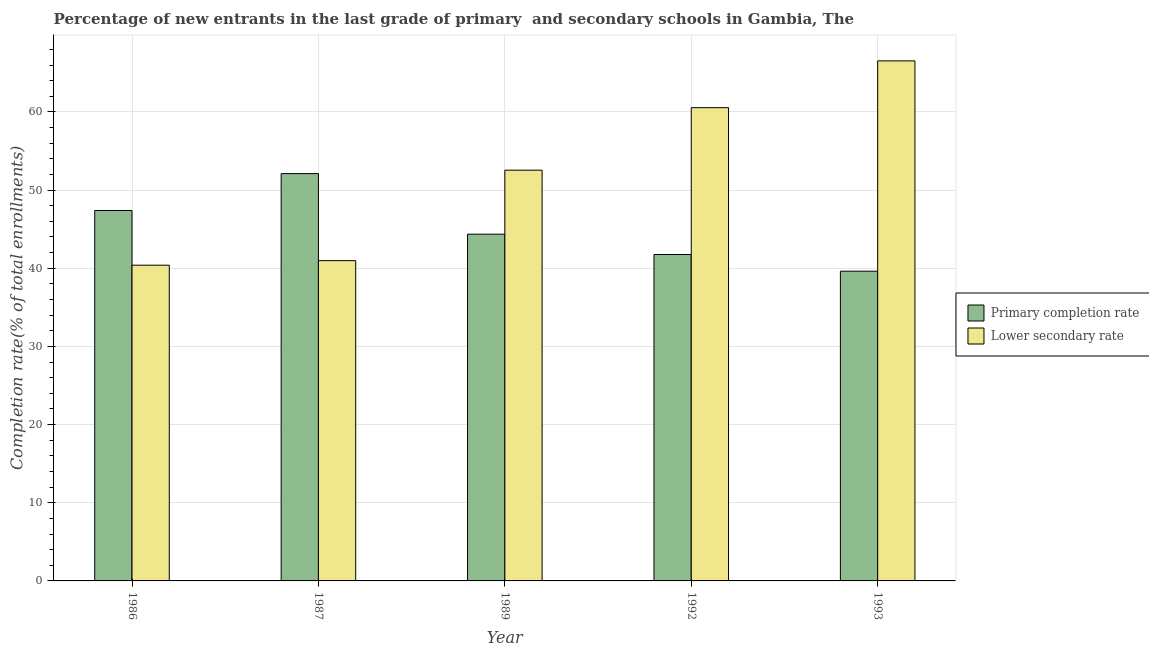Are the number of bars per tick equal to the number of legend labels?
Your response must be concise. Yes. How many bars are there on the 4th tick from the left?
Keep it short and to the point. 2. How many bars are there on the 4th tick from the right?
Your response must be concise. 2. What is the label of the 2nd group of bars from the left?
Provide a succinct answer. 1987. In how many cases, is the number of bars for a given year not equal to the number of legend labels?
Provide a succinct answer. 0. What is the completion rate in secondary schools in 1987?
Make the answer very short. 40.97. Across all years, what is the maximum completion rate in primary schools?
Offer a very short reply. 52.11. Across all years, what is the minimum completion rate in secondary schools?
Offer a very short reply. 40.39. In which year was the completion rate in primary schools maximum?
Give a very brief answer. 1987. What is the total completion rate in primary schools in the graph?
Keep it short and to the point. 225.23. What is the difference between the completion rate in secondary schools in 1989 and that in 1992?
Your answer should be compact. -8. What is the difference between the completion rate in primary schools in 1989 and the completion rate in secondary schools in 1992?
Provide a succinct answer. 2.6. What is the average completion rate in secondary schools per year?
Give a very brief answer. 52.2. In the year 1987, what is the difference between the completion rate in primary schools and completion rate in secondary schools?
Make the answer very short. 0. In how many years, is the completion rate in primary schools greater than 14 %?
Your response must be concise. 5. What is the ratio of the completion rate in primary schools in 1992 to that in 1993?
Keep it short and to the point. 1.05. Is the completion rate in primary schools in 1986 less than that in 1987?
Give a very brief answer. Yes. What is the difference between the highest and the second highest completion rate in primary schools?
Your response must be concise. 4.72. What is the difference between the highest and the lowest completion rate in secondary schools?
Your response must be concise. 26.14. What does the 2nd bar from the left in 1986 represents?
Your response must be concise. Lower secondary rate. What does the 2nd bar from the right in 1986 represents?
Provide a succinct answer. Primary completion rate. How many bars are there?
Give a very brief answer. 10. How many years are there in the graph?
Your answer should be very brief. 5. What is the difference between two consecutive major ticks on the Y-axis?
Make the answer very short. 10. Are the values on the major ticks of Y-axis written in scientific E-notation?
Your answer should be compact. No. Where does the legend appear in the graph?
Provide a short and direct response. Center right. What is the title of the graph?
Give a very brief answer. Percentage of new entrants in the last grade of primary  and secondary schools in Gambia, The. Does "Overweight" appear as one of the legend labels in the graph?
Make the answer very short. No. What is the label or title of the X-axis?
Your answer should be compact. Year. What is the label or title of the Y-axis?
Your response must be concise. Completion rate(% of total enrollments). What is the Completion rate(% of total enrollments) of Primary completion rate in 1986?
Offer a terse response. 47.39. What is the Completion rate(% of total enrollments) in Lower secondary rate in 1986?
Provide a succinct answer. 40.39. What is the Completion rate(% of total enrollments) in Primary completion rate in 1987?
Keep it short and to the point. 52.11. What is the Completion rate(% of total enrollments) in Lower secondary rate in 1987?
Ensure brevity in your answer.  40.97. What is the Completion rate(% of total enrollments) of Primary completion rate in 1989?
Offer a very short reply. 44.36. What is the Completion rate(% of total enrollments) of Lower secondary rate in 1989?
Provide a short and direct response. 52.55. What is the Completion rate(% of total enrollments) in Primary completion rate in 1992?
Provide a succinct answer. 41.76. What is the Completion rate(% of total enrollments) in Lower secondary rate in 1992?
Ensure brevity in your answer.  60.54. What is the Completion rate(% of total enrollments) of Primary completion rate in 1993?
Ensure brevity in your answer.  39.63. What is the Completion rate(% of total enrollments) in Lower secondary rate in 1993?
Keep it short and to the point. 66.53. Across all years, what is the maximum Completion rate(% of total enrollments) of Primary completion rate?
Your response must be concise. 52.11. Across all years, what is the maximum Completion rate(% of total enrollments) of Lower secondary rate?
Offer a very short reply. 66.53. Across all years, what is the minimum Completion rate(% of total enrollments) of Primary completion rate?
Offer a very short reply. 39.63. Across all years, what is the minimum Completion rate(% of total enrollments) in Lower secondary rate?
Offer a very short reply. 40.39. What is the total Completion rate(% of total enrollments) of Primary completion rate in the graph?
Keep it short and to the point. 225.23. What is the total Completion rate(% of total enrollments) in Lower secondary rate in the graph?
Provide a short and direct response. 260.98. What is the difference between the Completion rate(% of total enrollments) of Primary completion rate in 1986 and that in 1987?
Give a very brief answer. -4.72. What is the difference between the Completion rate(% of total enrollments) in Lower secondary rate in 1986 and that in 1987?
Offer a very short reply. -0.58. What is the difference between the Completion rate(% of total enrollments) in Primary completion rate in 1986 and that in 1989?
Your response must be concise. 3.03. What is the difference between the Completion rate(% of total enrollments) in Lower secondary rate in 1986 and that in 1989?
Provide a succinct answer. -12.15. What is the difference between the Completion rate(% of total enrollments) of Primary completion rate in 1986 and that in 1992?
Make the answer very short. 5.63. What is the difference between the Completion rate(% of total enrollments) in Lower secondary rate in 1986 and that in 1992?
Offer a terse response. -20.15. What is the difference between the Completion rate(% of total enrollments) of Primary completion rate in 1986 and that in 1993?
Keep it short and to the point. 7.76. What is the difference between the Completion rate(% of total enrollments) in Lower secondary rate in 1986 and that in 1993?
Give a very brief answer. -26.14. What is the difference between the Completion rate(% of total enrollments) in Primary completion rate in 1987 and that in 1989?
Provide a short and direct response. 7.75. What is the difference between the Completion rate(% of total enrollments) in Lower secondary rate in 1987 and that in 1989?
Keep it short and to the point. -11.57. What is the difference between the Completion rate(% of total enrollments) of Primary completion rate in 1987 and that in 1992?
Your answer should be compact. 10.35. What is the difference between the Completion rate(% of total enrollments) of Lower secondary rate in 1987 and that in 1992?
Ensure brevity in your answer.  -19.57. What is the difference between the Completion rate(% of total enrollments) of Primary completion rate in 1987 and that in 1993?
Your answer should be very brief. 12.48. What is the difference between the Completion rate(% of total enrollments) in Lower secondary rate in 1987 and that in 1993?
Your response must be concise. -25.56. What is the difference between the Completion rate(% of total enrollments) in Primary completion rate in 1989 and that in 1992?
Make the answer very short. 2.6. What is the difference between the Completion rate(% of total enrollments) of Lower secondary rate in 1989 and that in 1992?
Provide a succinct answer. -8. What is the difference between the Completion rate(% of total enrollments) in Primary completion rate in 1989 and that in 1993?
Your answer should be very brief. 4.73. What is the difference between the Completion rate(% of total enrollments) in Lower secondary rate in 1989 and that in 1993?
Keep it short and to the point. -13.98. What is the difference between the Completion rate(% of total enrollments) in Primary completion rate in 1992 and that in 1993?
Offer a terse response. 2.13. What is the difference between the Completion rate(% of total enrollments) in Lower secondary rate in 1992 and that in 1993?
Give a very brief answer. -5.99. What is the difference between the Completion rate(% of total enrollments) in Primary completion rate in 1986 and the Completion rate(% of total enrollments) in Lower secondary rate in 1987?
Offer a very short reply. 6.41. What is the difference between the Completion rate(% of total enrollments) in Primary completion rate in 1986 and the Completion rate(% of total enrollments) in Lower secondary rate in 1989?
Keep it short and to the point. -5.16. What is the difference between the Completion rate(% of total enrollments) in Primary completion rate in 1986 and the Completion rate(% of total enrollments) in Lower secondary rate in 1992?
Offer a terse response. -13.16. What is the difference between the Completion rate(% of total enrollments) in Primary completion rate in 1986 and the Completion rate(% of total enrollments) in Lower secondary rate in 1993?
Provide a succinct answer. -19.14. What is the difference between the Completion rate(% of total enrollments) of Primary completion rate in 1987 and the Completion rate(% of total enrollments) of Lower secondary rate in 1989?
Your answer should be very brief. -0.44. What is the difference between the Completion rate(% of total enrollments) of Primary completion rate in 1987 and the Completion rate(% of total enrollments) of Lower secondary rate in 1992?
Your answer should be compact. -8.44. What is the difference between the Completion rate(% of total enrollments) in Primary completion rate in 1987 and the Completion rate(% of total enrollments) in Lower secondary rate in 1993?
Your answer should be very brief. -14.42. What is the difference between the Completion rate(% of total enrollments) in Primary completion rate in 1989 and the Completion rate(% of total enrollments) in Lower secondary rate in 1992?
Your answer should be very brief. -16.18. What is the difference between the Completion rate(% of total enrollments) of Primary completion rate in 1989 and the Completion rate(% of total enrollments) of Lower secondary rate in 1993?
Keep it short and to the point. -22.17. What is the difference between the Completion rate(% of total enrollments) in Primary completion rate in 1992 and the Completion rate(% of total enrollments) in Lower secondary rate in 1993?
Your response must be concise. -24.77. What is the average Completion rate(% of total enrollments) of Primary completion rate per year?
Your answer should be compact. 45.05. What is the average Completion rate(% of total enrollments) in Lower secondary rate per year?
Ensure brevity in your answer.  52.2. In the year 1986, what is the difference between the Completion rate(% of total enrollments) in Primary completion rate and Completion rate(% of total enrollments) in Lower secondary rate?
Offer a terse response. 6.99. In the year 1987, what is the difference between the Completion rate(% of total enrollments) in Primary completion rate and Completion rate(% of total enrollments) in Lower secondary rate?
Ensure brevity in your answer.  11.13. In the year 1989, what is the difference between the Completion rate(% of total enrollments) of Primary completion rate and Completion rate(% of total enrollments) of Lower secondary rate?
Ensure brevity in your answer.  -8.19. In the year 1992, what is the difference between the Completion rate(% of total enrollments) of Primary completion rate and Completion rate(% of total enrollments) of Lower secondary rate?
Give a very brief answer. -18.79. In the year 1993, what is the difference between the Completion rate(% of total enrollments) of Primary completion rate and Completion rate(% of total enrollments) of Lower secondary rate?
Your response must be concise. -26.9. What is the ratio of the Completion rate(% of total enrollments) in Primary completion rate in 1986 to that in 1987?
Keep it short and to the point. 0.91. What is the ratio of the Completion rate(% of total enrollments) of Lower secondary rate in 1986 to that in 1987?
Keep it short and to the point. 0.99. What is the ratio of the Completion rate(% of total enrollments) of Primary completion rate in 1986 to that in 1989?
Keep it short and to the point. 1.07. What is the ratio of the Completion rate(% of total enrollments) in Lower secondary rate in 1986 to that in 1989?
Keep it short and to the point. 0.77. What is the ratio of the Completion rate(% of total enrollments) of Primary completion rate in 1986 to that in 1992?
Make the answer very short. 1.13. What is the ratio of the Completion rate(% of total enrollments) in Lower secondary rate in 1986 to that in 1992?
Make the answer very short. 0.67. What is the ratio of the Completion rate(% of total enrollments) in Primary completion rate in 1986 to that in 1993?
Your answer should be compact. 1.2. What is the ratio of the Completion rate(% of total enrollments) of Lower secondary rate in 1986 to that in 1993?
Offer a terse response. 0.61. What is the ratio of the Completion rate(% of total enrollments) in Primary completion rate in 1987 to that in 1989?
Keep it short and to the point. 1.17. What is the ratio of the Completion rate(% of total enrollments) of Lower secondary rate in 1987 to that in 1989?
Your answer should be very brief. 0.78. What is the ratio of the Completion rate(% of total enrollments) of Primary completion rate in 1987 to that in 1992?
Make the answer very short. 1.25. What is the ratio of the Completion rate(% of total enrollments) in Lower secondary rate in 1987 to that in 1992?
Offer a terse response. 0.68. What is the ratio of the Completion rate(% of total enrollments) of Primary completion rate in 1987 to that in 1993?
Offer a terse response. 1.31. What is the ratio of the Completion rate(% of total enrollments) in Lower secondary rate in 1987 to that in 1993?
Offer a terse response. 0.62. What is the ratio of the Completion rate(% of total enrollments) of Primary completion rate in 1989 to that in 1992?
Offer a terse response. 1.06. What is the ratio of the Completion rate(% of total enrollments) of Lower secondary rate in 1989 to that in 1992?
Ensure brevity in your answer.  0.87. What is the ratio of the Completion rate(% of total enrollments) in Primary completion rate in 1989 to that in 1993?
Your response must be concise. 1.12. What is the ratio of the Completion rate(% of total enrollments) in Lower secondary rate in 1989 to that in 1993?
Make the answer very short. 0.79. What is the ratio of the Completion rate(% of total enrollments) in Primary completion rate in 1992 to that in 1993?
Keep it short and to the point. 1.05. What is the ratio of the Completion rate(% of total enrollments) of Lower secondary rate in 1992 to that in 1993?
Ensure brevity in your answer.  0.91. What is the difference between the highest and the second highest Completion rate(% of total enrollments) of Primary completion rate?
Your answer should be compact. 4.72. What is the difference between the highest and the second highest Completion rate(% of total enrollments) of Lower secondary rate?
Your response must be concise. 5.99. What is the difference between the highest and the lowest Completion rate(% of total enrollments) in Primary completion rate?
Your response must be concise. 12.48. What is the difference between the highest and the lowest Completion rate(% of total enrollments) in Lower secondary rate?
Provide a succinct answer. 26.14. 